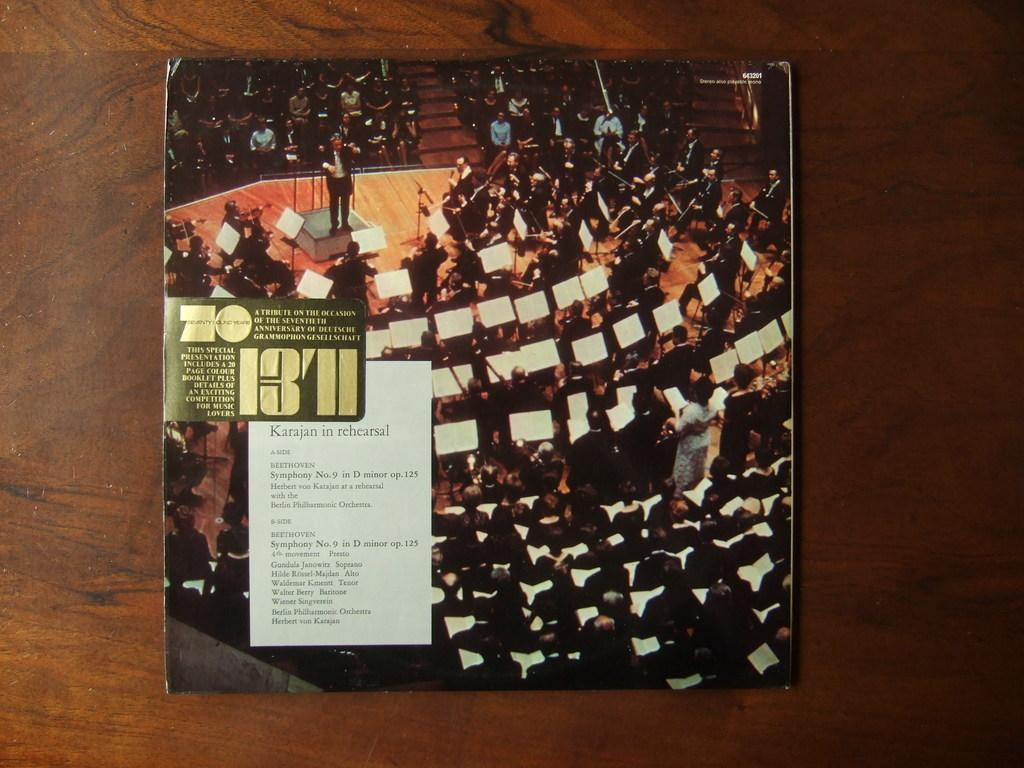Provide a one-sentence caption for the provided image. A symphony tribute on the occasion of the seventieth anniversary for a celebration. 